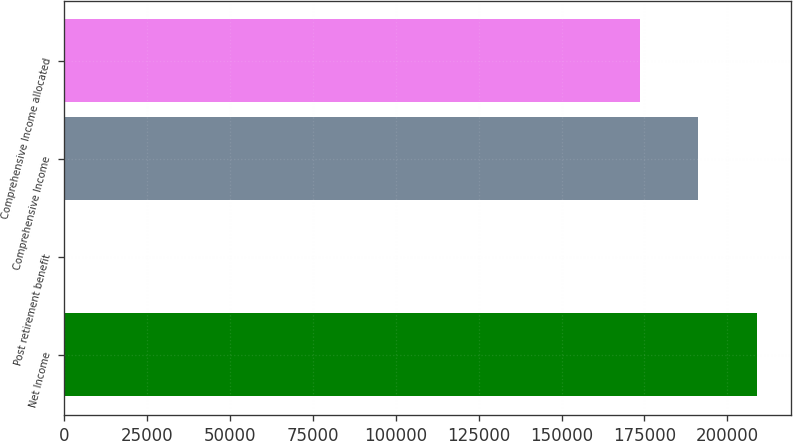Convert chart. <chart><loc_0><loc_0><loc_500><loc_500><bar_chart><fcel>Net Income<fcel>Post retirement benefit<fcel>Comprehensive Income<fcel>Comprehensive Income allocated<nl><fcel>208874<fcel>157<fcel>191290<fcel>173706<nl></chart> 